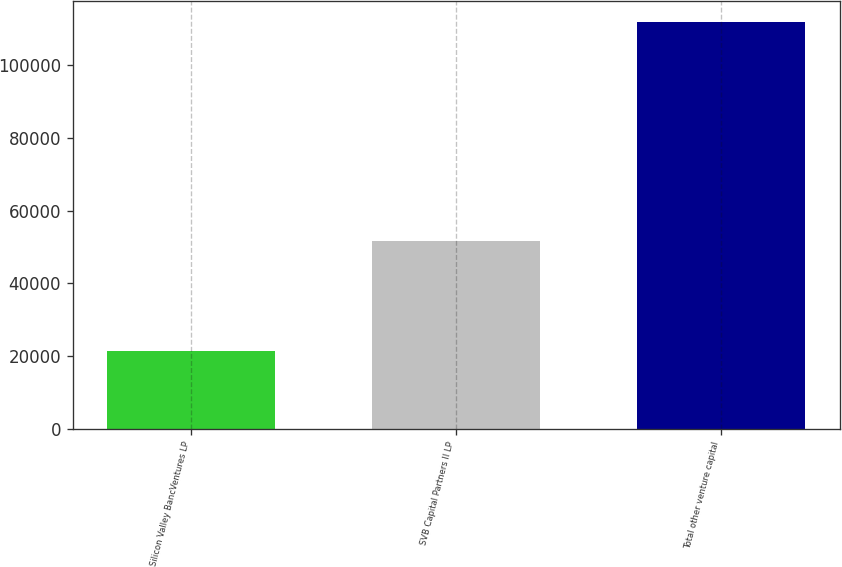<chart> <loc_0><loc_0><loc_500><loc_500><bar_chart><fcel>Silicon Valley BancVentures LP<fcel>SVB Capital Partners II LP<fcel>Total other venture capital<nl><fcel>21371<fcel>51545<fcel>111843<nl></chart> 